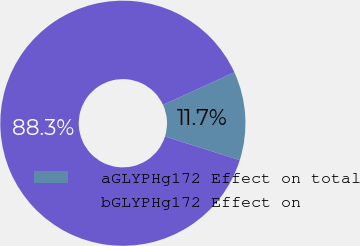<chart> <loc_0><loc_0><loc_500><loc_500><pie_chart><fcel>aGLYPHg172 Effect on total<fcel>bGLYPHg172 Effect on<nl><fcel>11.69%<fcel>88.31%<nl></chart> 